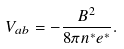<formula> <loc_0><loc_0><loc_500><loc_500>V _ { a b } = - \frac { B ^ { 2 } } { 8 \pi n ^ { \ast } e ^ { \ast } } .</formula> 